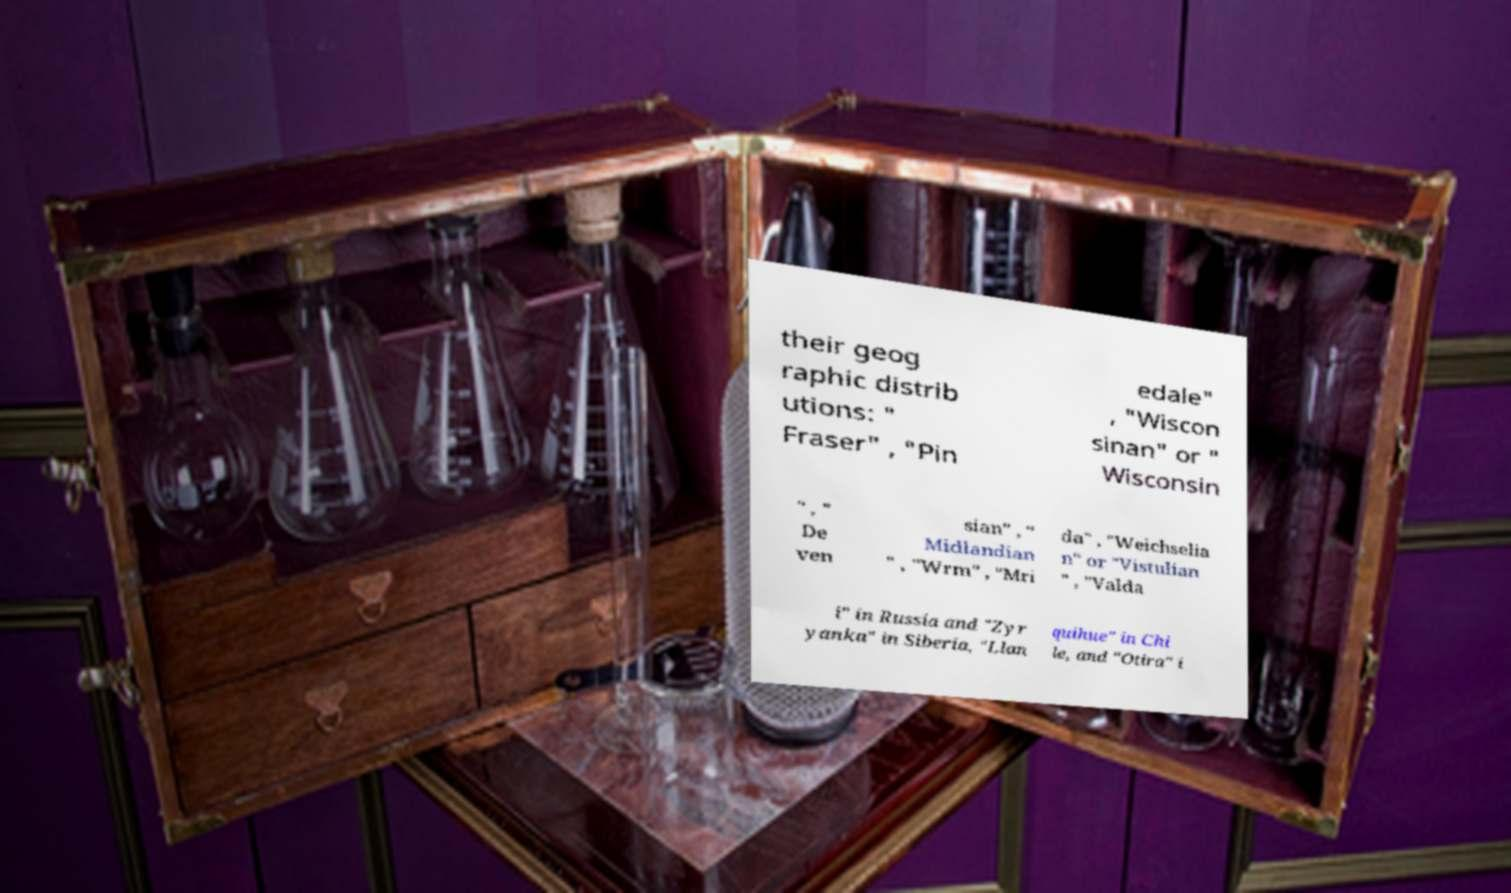Can you accurately transcribe the text from the provided image for me? their geog raphic distrib utions: " Fraser" , "Pin edale" , "Wiscon sinan" or " Wisconsin " , " De ven sian" , " Midlandian " , "Wrm" , "Mri da" , "Weichselia n" or "Vistulian " , "Valda i" in Russia and "Zyr yanka" in Siberia, "Llan quihue" in Chi le, and "Otira" i 